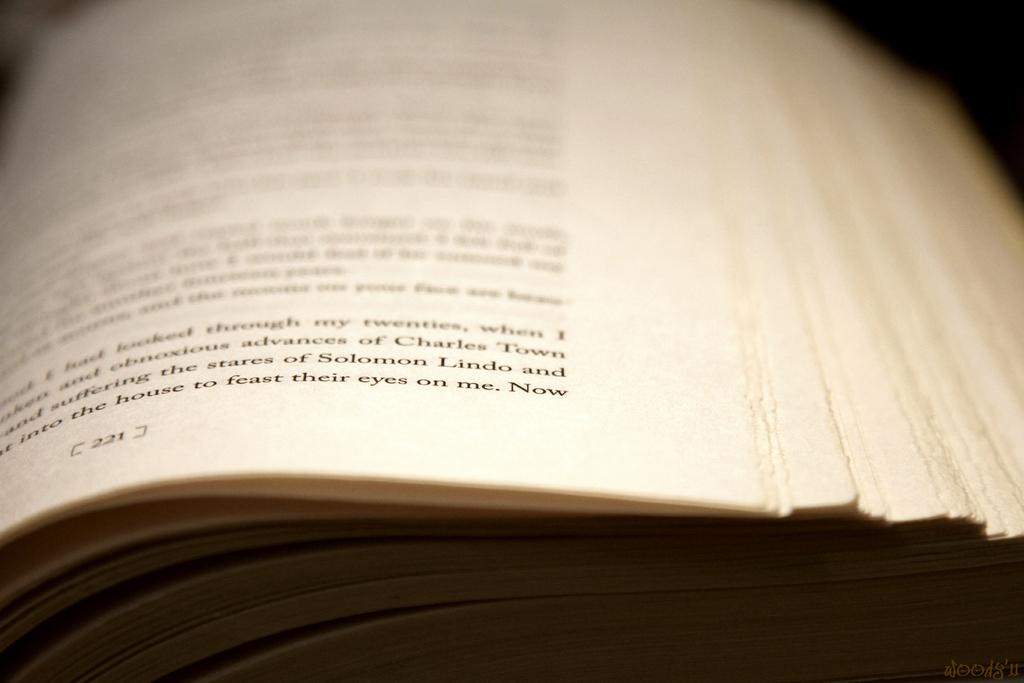Provide a one-sentence caption for the provided image. Part of a page of a book mentios Charles Town and Solomon Lindo. 